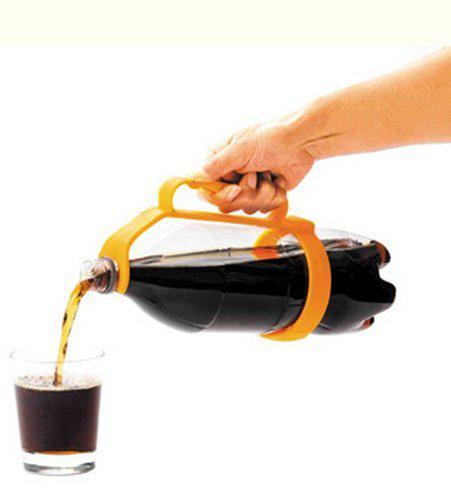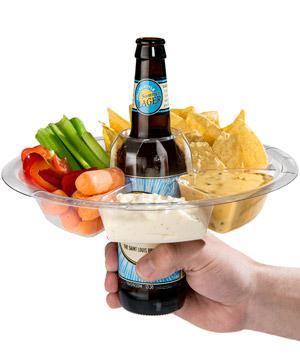The first image is the image on the left, the second image is the image on the right. Evaluate the accuracy of this statement regarding the images: "An image shows one hand gripping a handle attached to a horizontal bottle pouring cola into a glass under it on the left.". Is it true? Answer yes or no. Yes. The first image is the image on the left, the second image is the image on the right. Analyze the images presented: Is the assertion "A person is pouring out the soda in one of the images." valid? Answer yes or no. Yes. 